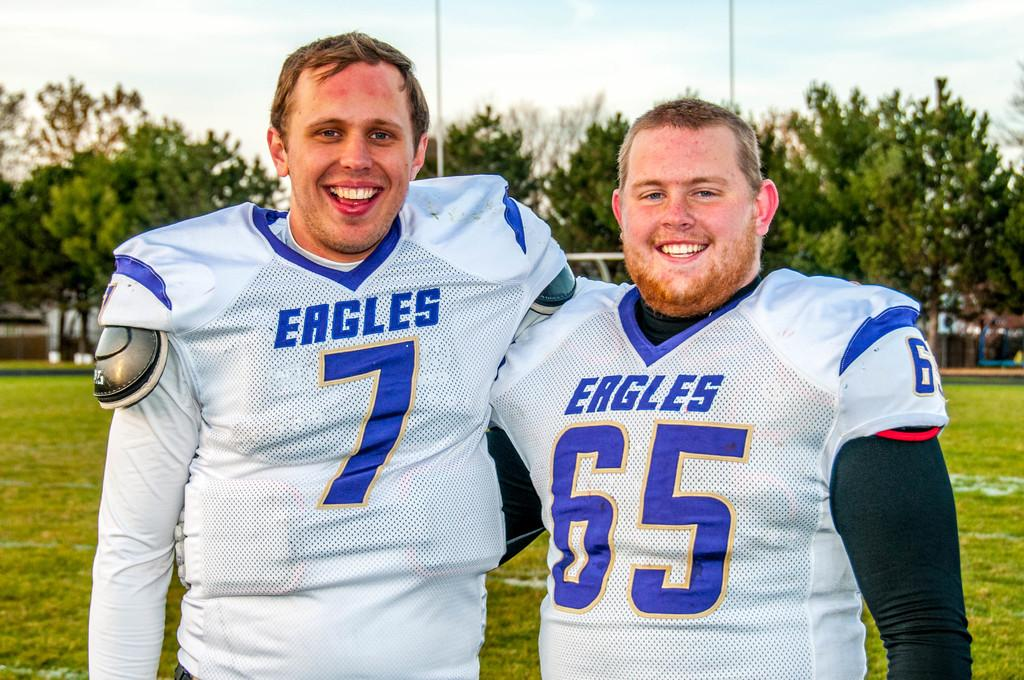<image>
Summarize the visual content of the image. two football players from the team eagles in white jerseys 